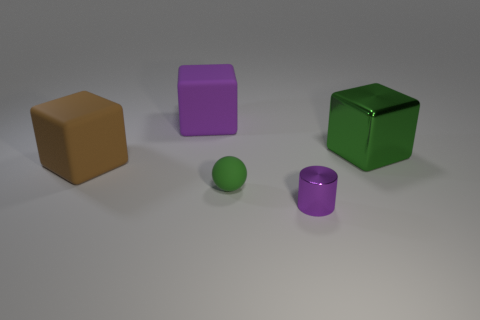Is the number of big brown rubber objects greater than the number of yellow cylinders? After carefully examining the image, it appears that there is one large brown rubber-like object and no yellow cylinders present; hence, the number of big brown rubber objects is indeed greater than the number of yellow cylinders, which stands at zero. 